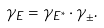<formula> <loc_0><loc_0><loc_500><loc_500>\gamma _ { E } = \gamma _ { E ^ { * } } \cdot \gamma _ { \pm } .</formula> 